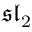Convert formula to latex. <formula><loc_0><loc_0><loc_500><loc_500>{ \mathfrak { s l } } _ { 2 }</formula> 